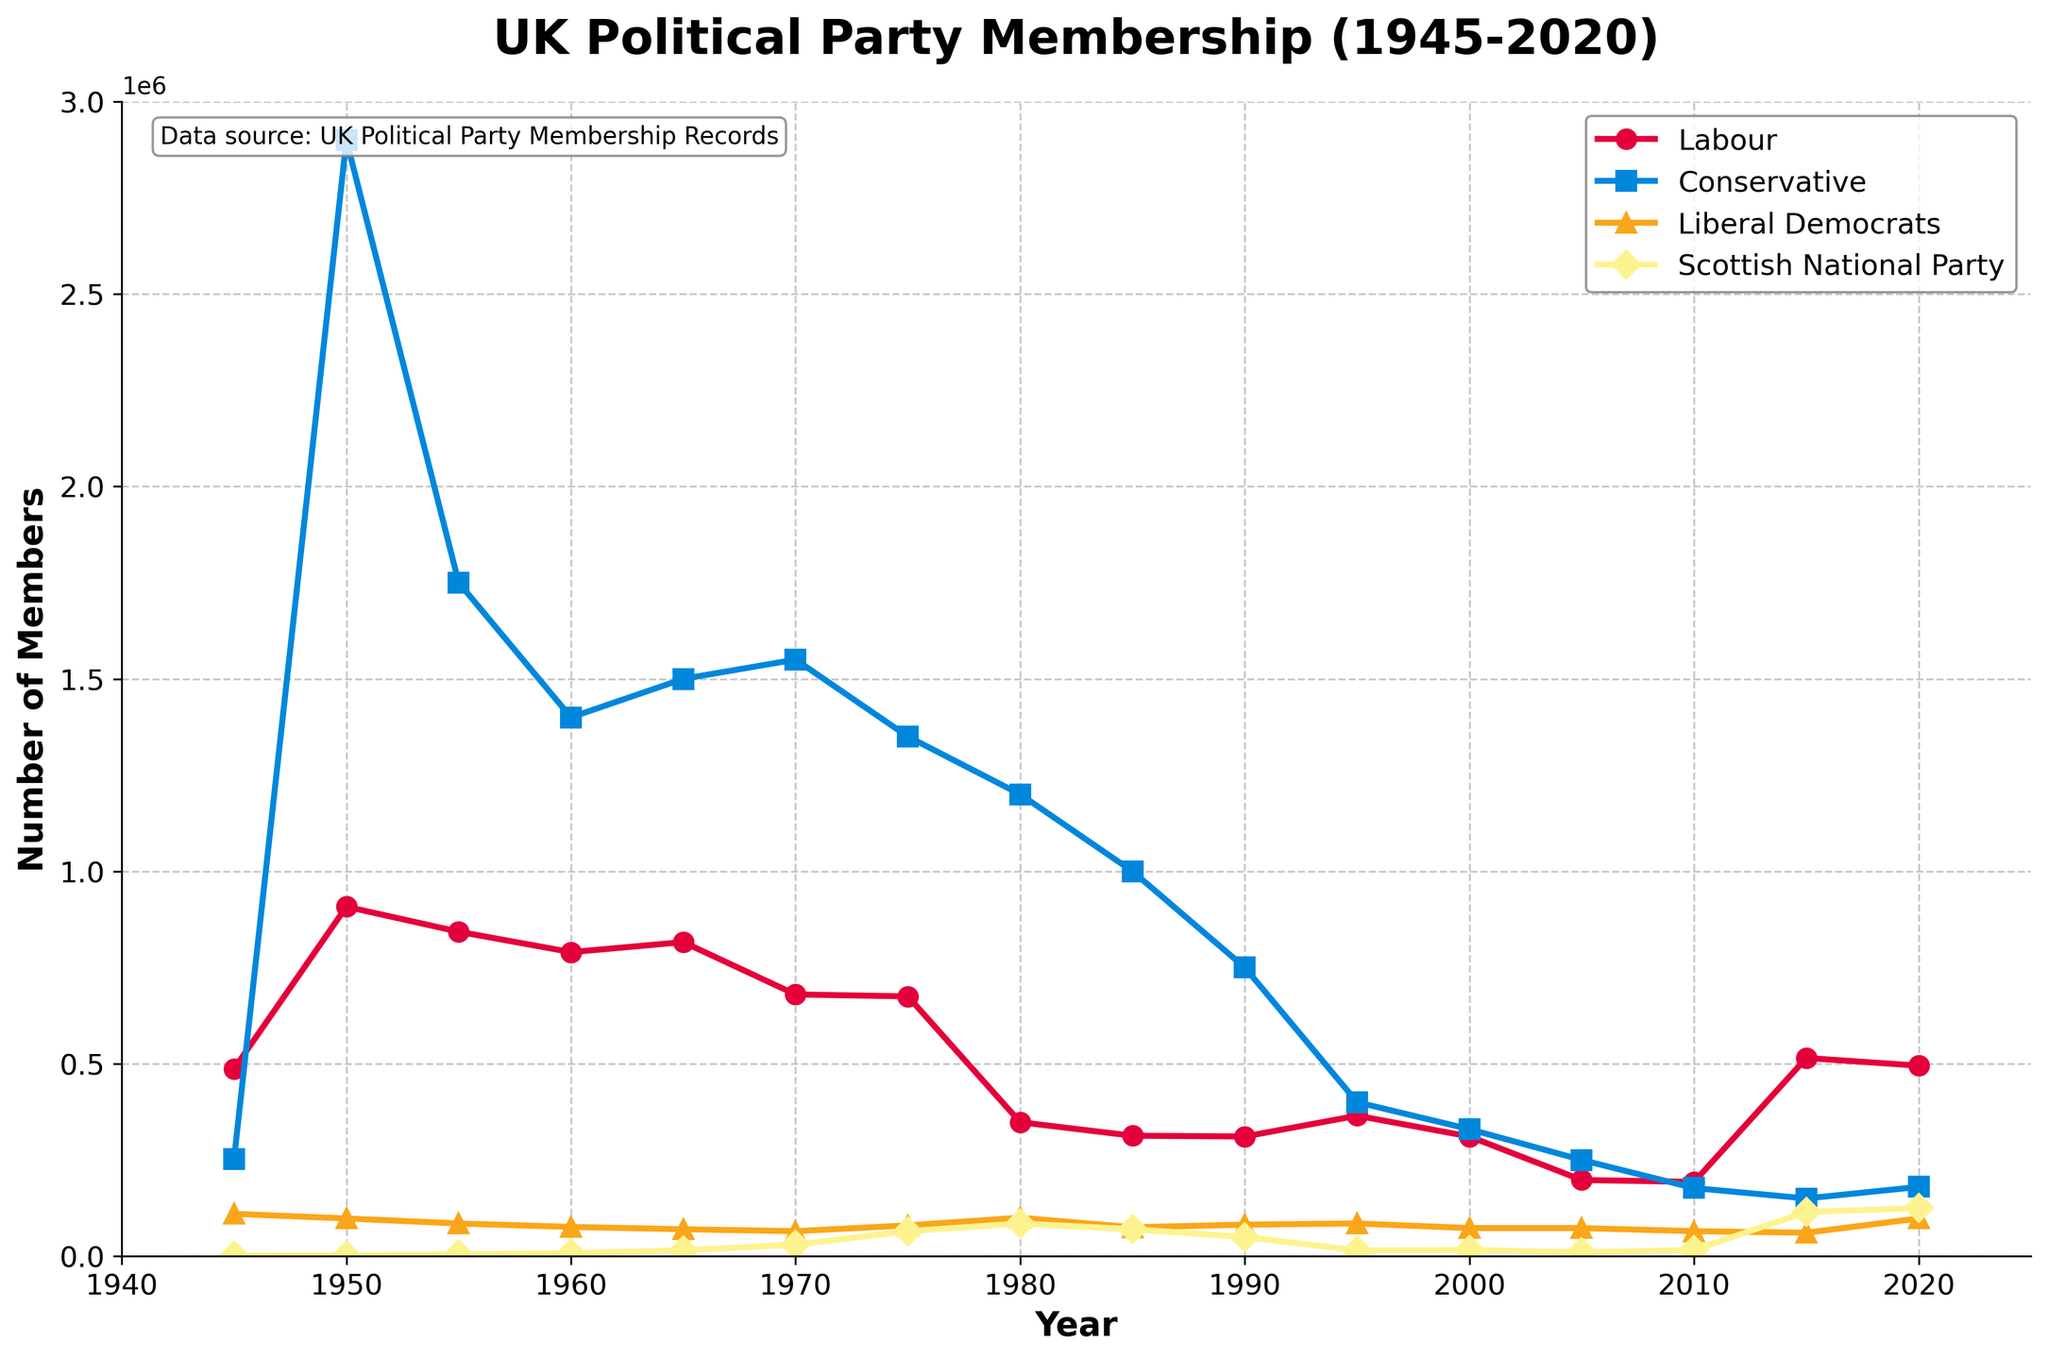What was the membership number of the Labour Party in 1945 and 2015? To find the membership numbers for 1945 and 2015, locate these years on the x-axis and read the corresponding values on the y-axis from the Labour Party's line. In 1945, the Labour Party had 487,000 members, and in 2015, it had 515,000 members.
Answer: 487,000 and 515,000 Which political party had the highest membership in 1950? Look at the year 1950 along the x-axis and compare the corresponding y-axis values for all the parties. The Conservative Party's line is the highest at 2,900,000 members in 1950.
Answer: Conservative Party How did the membership of the Scottish National Party (SNP) change from 1945 to 2020? Locate the years 1945 and 2020 on the x-axis, and read the y-axis values for the SNP's line. The SNP rose from 1,000 members in 1945 to 125,000 members in 2020.
Answer: From 1,000 to 125,000 Which party showed the most significant drop in membership from 1950 to 2010? Compare the size of the drops by reading the y-axis values for each party in 1950 and 2010 and calculating the differences. The Conservative Party dropped from 2,900,000 in 1950 to 177,000 in 2010, a decrease of 2,723,000, which is the largest drop.
Answer: Conservative Party In what year did the Labour Party's membership fall below 400,000, and when did it rise again above 400,000? Locate the Labour Party line and identify the first year after 1950 when the membership fell below 400,000, which is 1990. Then, find when it rose above 400,000 again, which is 2015.
Answer: Fell below in 1990, rose above in 2015 From 1945 to 2020, during which year did the Liberal Democrats experience their highest membership? Follow the Liberal Democrats' line and find the highest point on the y-axis. The highest membership for Liberal Democrats was in 1980, with a membership of 100,000.
Answer: 1980 What is the overall trend in the Conservative Party's membership from 1945 to 2020? Trace the Conservative Party's line from 1945 to 2020. The general trend is a significant decrease from 2,530,000 members in 1945 to 180,000 members in 2020.
Answer: Decreasing trend Compare the membership of Labour and Conservative parties in 2000. Which party had more members and by how much? Locate the year 2000 and compare the y-axis values for Labour and Conservative. Labour had 311,000 members, and Conservative had 330,000 members. The Conservative Party had 19,000 more members.
Answer: Conservative by 19,000 What is the average membership of the Labour Party in the years 1945, 1950, 1955, and 1960? Add up the Labour membership numbers for 1945 (487,000), 1950 (908,000), 1955 (843,000), and 1960 (790,000) and divide by 4. Average = (487,000 + 908,000 + 843,000 + 790,000) / 4 = 757,000.
Answer: 757,000 